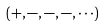<formula> <loc_0><loc_0><loc_500><loc_500>( + , - , - , - , \cdot \cdot \cdot )</formula> 